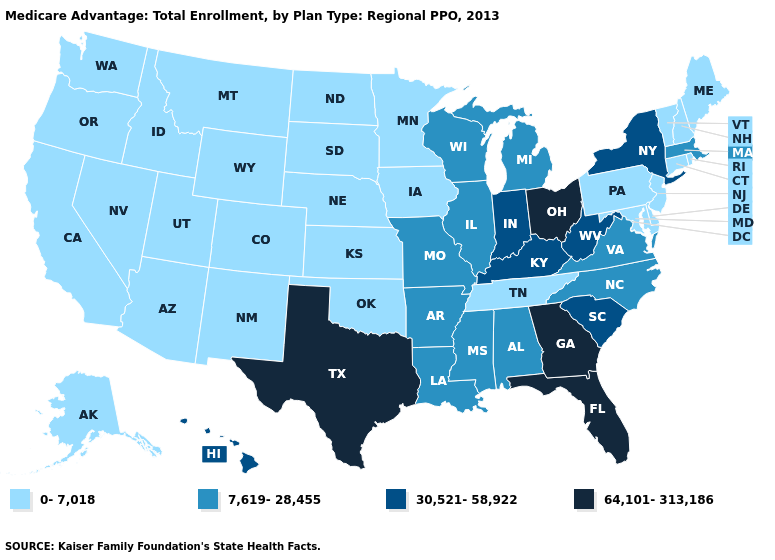Does Utah have the same value as South Carolina?
Give a very brief answer. No. Is the legend a continuous bar?
Be succinct. No. How many symbols are there in the legend?
Short answer required. 4. Among the states that border Iowa , does Missouri have the highest value?
Answer briefly. Yes. What is the value of Massachusetts?
Keep it brief. 7,619-28,455. Which states have the lowest value in the West?
Write a very short answer. Alaska, Arizona, California, Colorado, Idaho, Montana, New Mexico, Nevada, Oregon, Utah, Washington, Wyoming. Does the first symbol in the legend represent the smallest category?
Quick response, please. Yes. What is the lowest value in the USA?
Answer briefly. 0-7,018. Which states have the lowest value in the USA?
Be succinct. Alaska, Arizona, California, Colorado, Connecticut, Delaware, Iowa, Idaho, Kansas, Maryland, Maine, Minnesota, Montana, North Dakota, Nebraska, New Hampshire, New Jersey, New Mexico, Nevada, Oklahoma, Oregon, Pennsylvania, Rhode Island, South Dakota, Tennessee, Utah, Vermont, Washington, Wyoming. What is the lowest value in the South?
Give a very brief answer. 0-7,018. What is the value of Illinois?
Keep it brief. 7,619-28,455. What is the highest value in states that border Virginia?
Keep it brief. 30,521-58,922. Name the states that have a value in the range 7,619-28,455?
Write a very short answer. Alabama, Arkansas, Illinois, Louisiana, Massachusetts, Michigan, Missouri, Mississippi, North Carolina, Virginia, Wisconsin. What is the highest value in the USA?
Give a very brief answer. 64,101-313,186. What is the value of Nebraska?
Keep it brief. 0-7,018. 